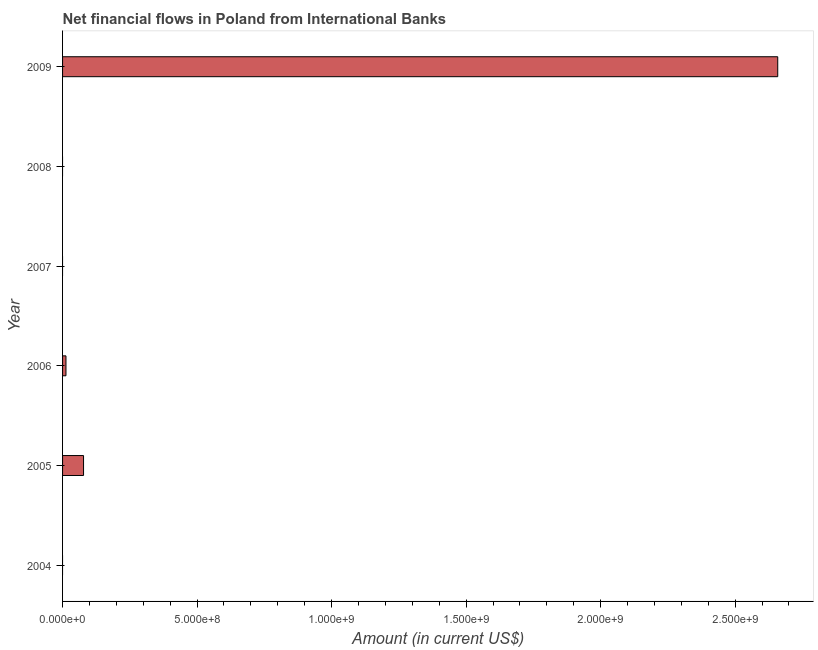What is the title of the graph?
Keep it short and to the point. Net financial flows in Poland from International Banks. What is the label or title of the X-axis?
Keep it short and to the point. Amount (in current US$). What is the label or title of the Y-axis?
Your response must be concise. Year. What is the net financial flows from ibrd in 2004?
Your response must be concise. 0. Across all years, what is the maximum net financial flows from ibrd?
Your response must be concise. 2.66e+09. Across all years, what is the minimum net financial flows from ibrd?
Provide a succinct answer. 0. In which year was the net financial flows from ibrd maximum?
Your response must be concise. 2009. What is the sum of the net financial flows from ibrd?
Your answer should be very brief. 2.75e+09. What is the average net financial flows from ibrd per year?
Your answer should be compact. 4.58e+08. What is the median net financial flows from ibrd?
Give a very brief answer. 6.33e+06. In how many years, is the net financial flows from ibrd greater than 1800000000 US$?
Make the answer very short. 1. What is the ratio of the net financial flows from ibrd in 2005 to that in 2006?
Provide a succinct answer. 6.16. Is the net financial flows from ibrd in 2006 less than that in 2009?
Provide a succinct answer. Yes. Is the difference between the net financial flows from ibrd in 2005 and 2009 greater than the difference between any two years?
Your answer should be compact. No. What is the difference between the highest and the second highest net financial flows from ibrd?
Your response must be concise. 2.58e+09. Is the sum of the net financial flows from ibrd in 2005 and 2006 greater than the maximum net financial flows from ibrd across all years?
Keep it short and to the point. No. What is the difference between the highest and the lowest net financial flows from ibrd?
Offer a terse response. 2.66e+09. In how many years, is the net financial flows from ibrd greater than the average net financial flows from ibrd taken over all years?
Keep it short and to the point. 1. Are all the bars in the graph horizontal?
Your response must be concise. Yes. What is the difference between two consecutive major ticks on the X-axis?
Offer a very short reply. 5.00e+08. What is the Amount (in current US$) in 2004?
Make the answer very short. 0. What is the Amount (in current US$) in 2005?
Ensure brevity in your answer.  7.80e+07. What is the Amount (in current US$) in 2006?
Offer a terse response. 1.27e+07. What is the Amount (in current US$) in 2008?
Provide a succinct answer. 0. What is the Amount (in current US$) of 2009?
Keep it short and to the point. 2.66e+09. What is the difference between the Amount (in current US$) in 2005 and 2006?
Your answer should be very brief. 6.53e+07. What is the difference between the Amount (in current US$) in 2005 and 2009?
Your response must be concise. -2.58e+09. What is the difference between the Amount (in current US$) in 2006 and 2009?
Offer a terse response. -2.65e+09. What is the ratio of the Amount (in current US$) in 2005 to that in 2006?
Your answer should be compact. 6.16. What is the ratio of the Amount (in current US$) in 2005 to that in 2009?
Keep it short and to the point. 0.03. What is the ratio of the Amount (in current US$) in 2006 to that in 2009?
Your answer should be very brief. 0.01. 